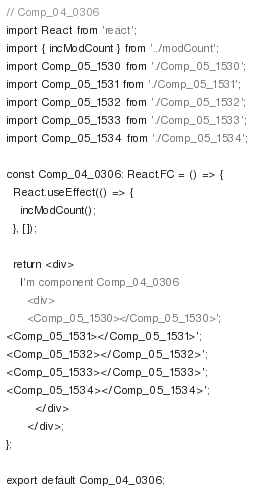<code> <loc_0><loc_0><loc_500><loc_500><_TypeScript_>// Comp_04_0306
import React from 'react';
import { incModCount } from '../modCount';
import Comp_05_1530 from './Comp_05_1530';
import Comp_05_1531 from './Comp_05_1531';
import Comp_05_1532 from './Comp_05_1532';
import Comp_05_1533 from './Comp_05_1533';
import Comp_05_1534 from './Comp_05_1534';

const Comp_04_0306: React.FC = () => {
  React.useEffect(() => {
    incModCount();
  }, []);

  return <div>
    I'm component Comp_04_0306
      <div>
      <Comp_05_1530></Comp_05_1530>';
<Comp_05_1531></Comp_05_1531>';
<Comp_05_1532></Comp_05_1532>';
<Comp_05_1533></Comp_05_1533>';
<Comp_05_1534></Comp_05_1534>';
        </div>
      </div>;
};

export default Comp_04_0306;
</code> 